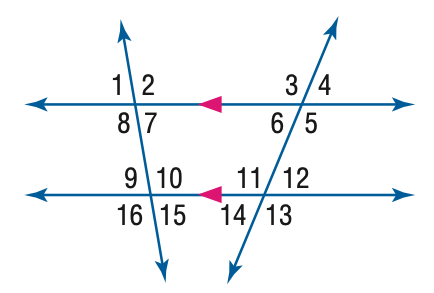In the figure, m \angle 8 = 96 and m \angle 12 = 42. Find the measure of \angle 9. Given the geometric properties of angles formed by intersecting lines, we can deduce that angles 8 and 9 are supplementary because they are a linear pair. This means that they add up to 180 degrees. With m \angle 8 given as 96 degrees, to find m \angle 9, we subtract 96 degrees from 180 degrees, resulting in m \angle 9 being 84 degrees. Therefore, the correct answer is B: 84. 